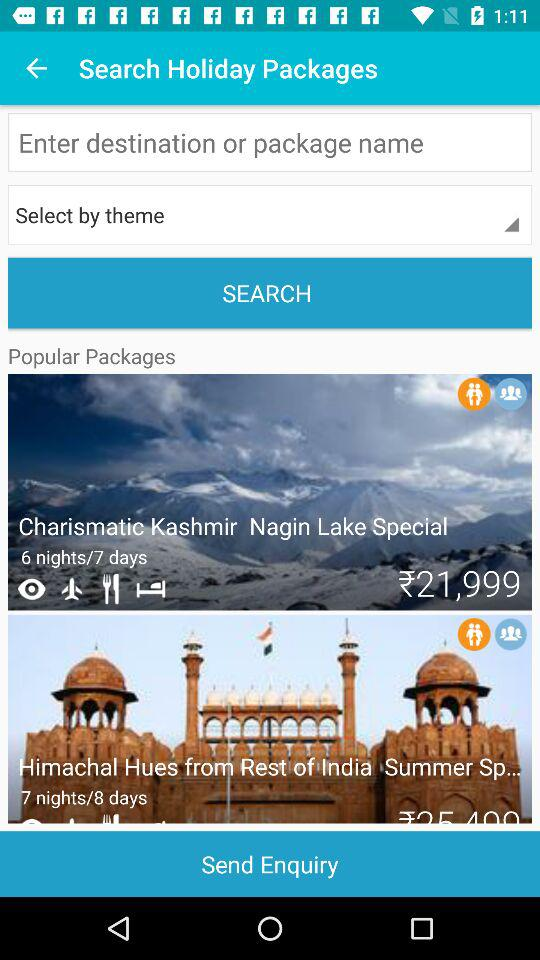How many more nights does the second package have than the first? 1 